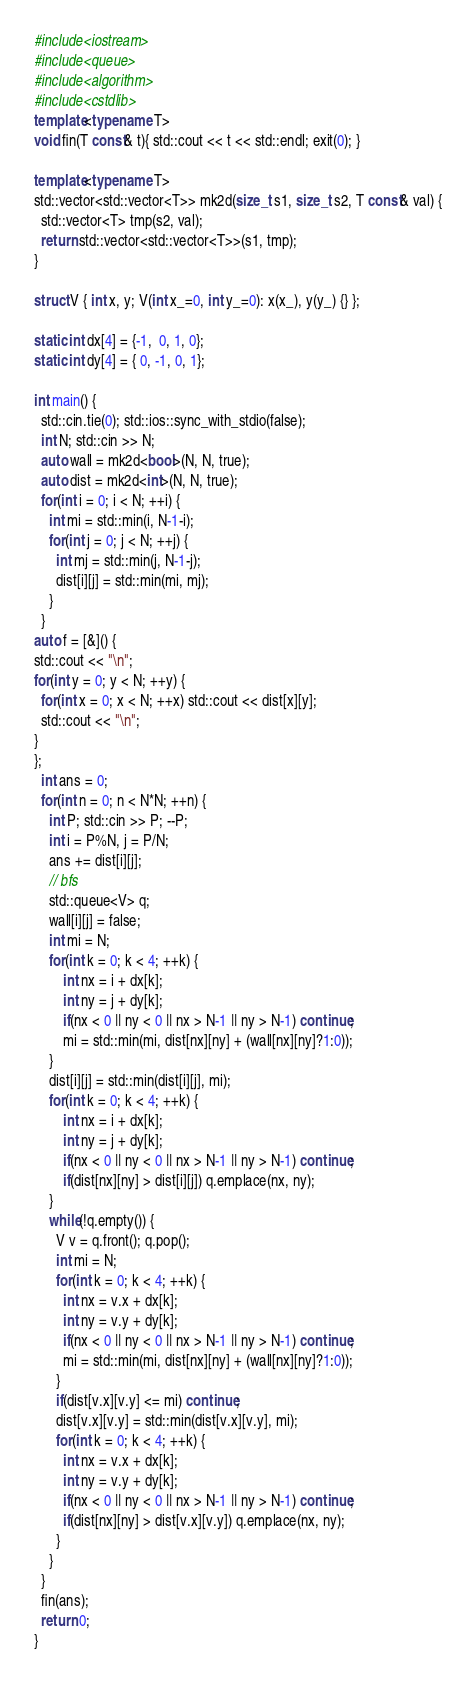Convert code to text. <code><loc_0><loc_0><loc_500><loc_500><_C++_>#include<iostream>
#include<queue>
#include<algorithm>
#include<cstdlib>
template<typename T>
void fin(T const& t){ std::cout << t << std::endl; exit(0); }

template<typename T>
std::vector<std::vector<T>> mk2d(size_t s1, size_t s2, T const& val) {
  std::vector<T> tmp(s2, val);
  return std::vector<std::vector<T>>(s1, tmp);
}

struct V { int x, y; V(int x_=0, int y_=0): x(x_), y(y_) {} };

static int dx[4] = {-1,  0, 1, 0};
static int dy[4] = { 0, -1, 0, 1};

int main() {
  std::cin.tie(0); std::ios::sync_with_stdio(false);
  int N; std::cin >> N;
  auto wall = mk2d<bool>(N, N, true);
  auto dist = mk2d<int>(N, N, true);
  for(int i = 0; i < N; ++i) {
    int mi = std::min(i, N-1-i);
    for(int j = 0; j < N; ++j) {
      int mj = std::min(j, N-1-j);
      dist[i][j] = std::min(mi, mj);
    }
  }
auto f = [&]() {
std::cout << "\n"; 
for(int y = 0; y < N; ++y) {
  for(int x = 0; x < N; ++x) std::cout << dist[x][y];
  std::cout << "\n";
}
};
  int ans = 0;
  for(int n = 0; n < N*N; ++n) {
    int P; std::cin >> P; --P;
    int i = P%N, j = P/N;
    ans += dist[i][j];
    // bfs
    std::queue<V> q;
    wall[i][j] = false;
    int mi = N;
    for(int k = 0; k < 4; ++k) {
        int nx = i + dx[k];
        int ny = j + dy[k];
        if(nx < 0 || ny < 0 || nx > N-1 || ny > N-1) continue;
        mi = std::min(mi, dist[nx][ny] + (wall[nx][ny]?1:0));
    }
    dist[i][j] = std::min(dist[i][j], mi);
    for(int k = 0; k < 4; ++k) {
        int nx = i + dx[k];
        int ny = j + dy[k];
        if(nx < 0 || ny < 0 || nx > N-1 || ny > N-1) continue;
        if(dist[nx][ny] > dist[i][j]) q.emplace(nx, ny);
    }
    while(!q.empty()) {
      V v = q.front(); q.pop();
      int mi = N;
      for(int k = 0; k < 4; ++k) {
        int nx = v.x + dx[k];
        int ny = v.y + dy[k];
        if(nx < 0 || ny < 0 || nx > N-1 || ny > N-1) continue;
        mi = std::min(mi, dist[nx][ny] + (wall[nx][ny]?1:0));
      }
      if(dist[v.x][v.y] <= mi) continue;
      dist[v.x][v.y] = std::min(dist[v.x][v.y], mi);
      for(int k = 0; k < 4; ++k) {
        int nx = v.x + dx[k];
        int ny = v.y + dy[k];
        if(nx < 0 || ny < 0 || nx > N-1 || ny > N-1) continue;
        if(dist[nx][ny] > dist[v.x][v.y]) q.emplace(nx, ny);
      }
    }
  }
  fin(ans);
  return 0;
}
</code> 